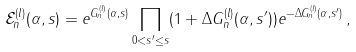<formula> <loc_0><loc_0><loc_500><loc_500>\mathcal { E } ^ { ( l ) } _ { n } ( \alpha , s ) = e ^ { G ^ { ( l ) } _ { n } ( \alpha , s ) } \prod _ { 0 < s ^ { \prime } \leq s } ( 1 + \Delta G ^ { ( l ) } _ { n } ( \alpha , s ^ { \prime } ) ) e ^ { - \Delta G ^ { ( l ) } _ { n } ( \alpha , s ^ { \prime } ) } \, ,</formula> 